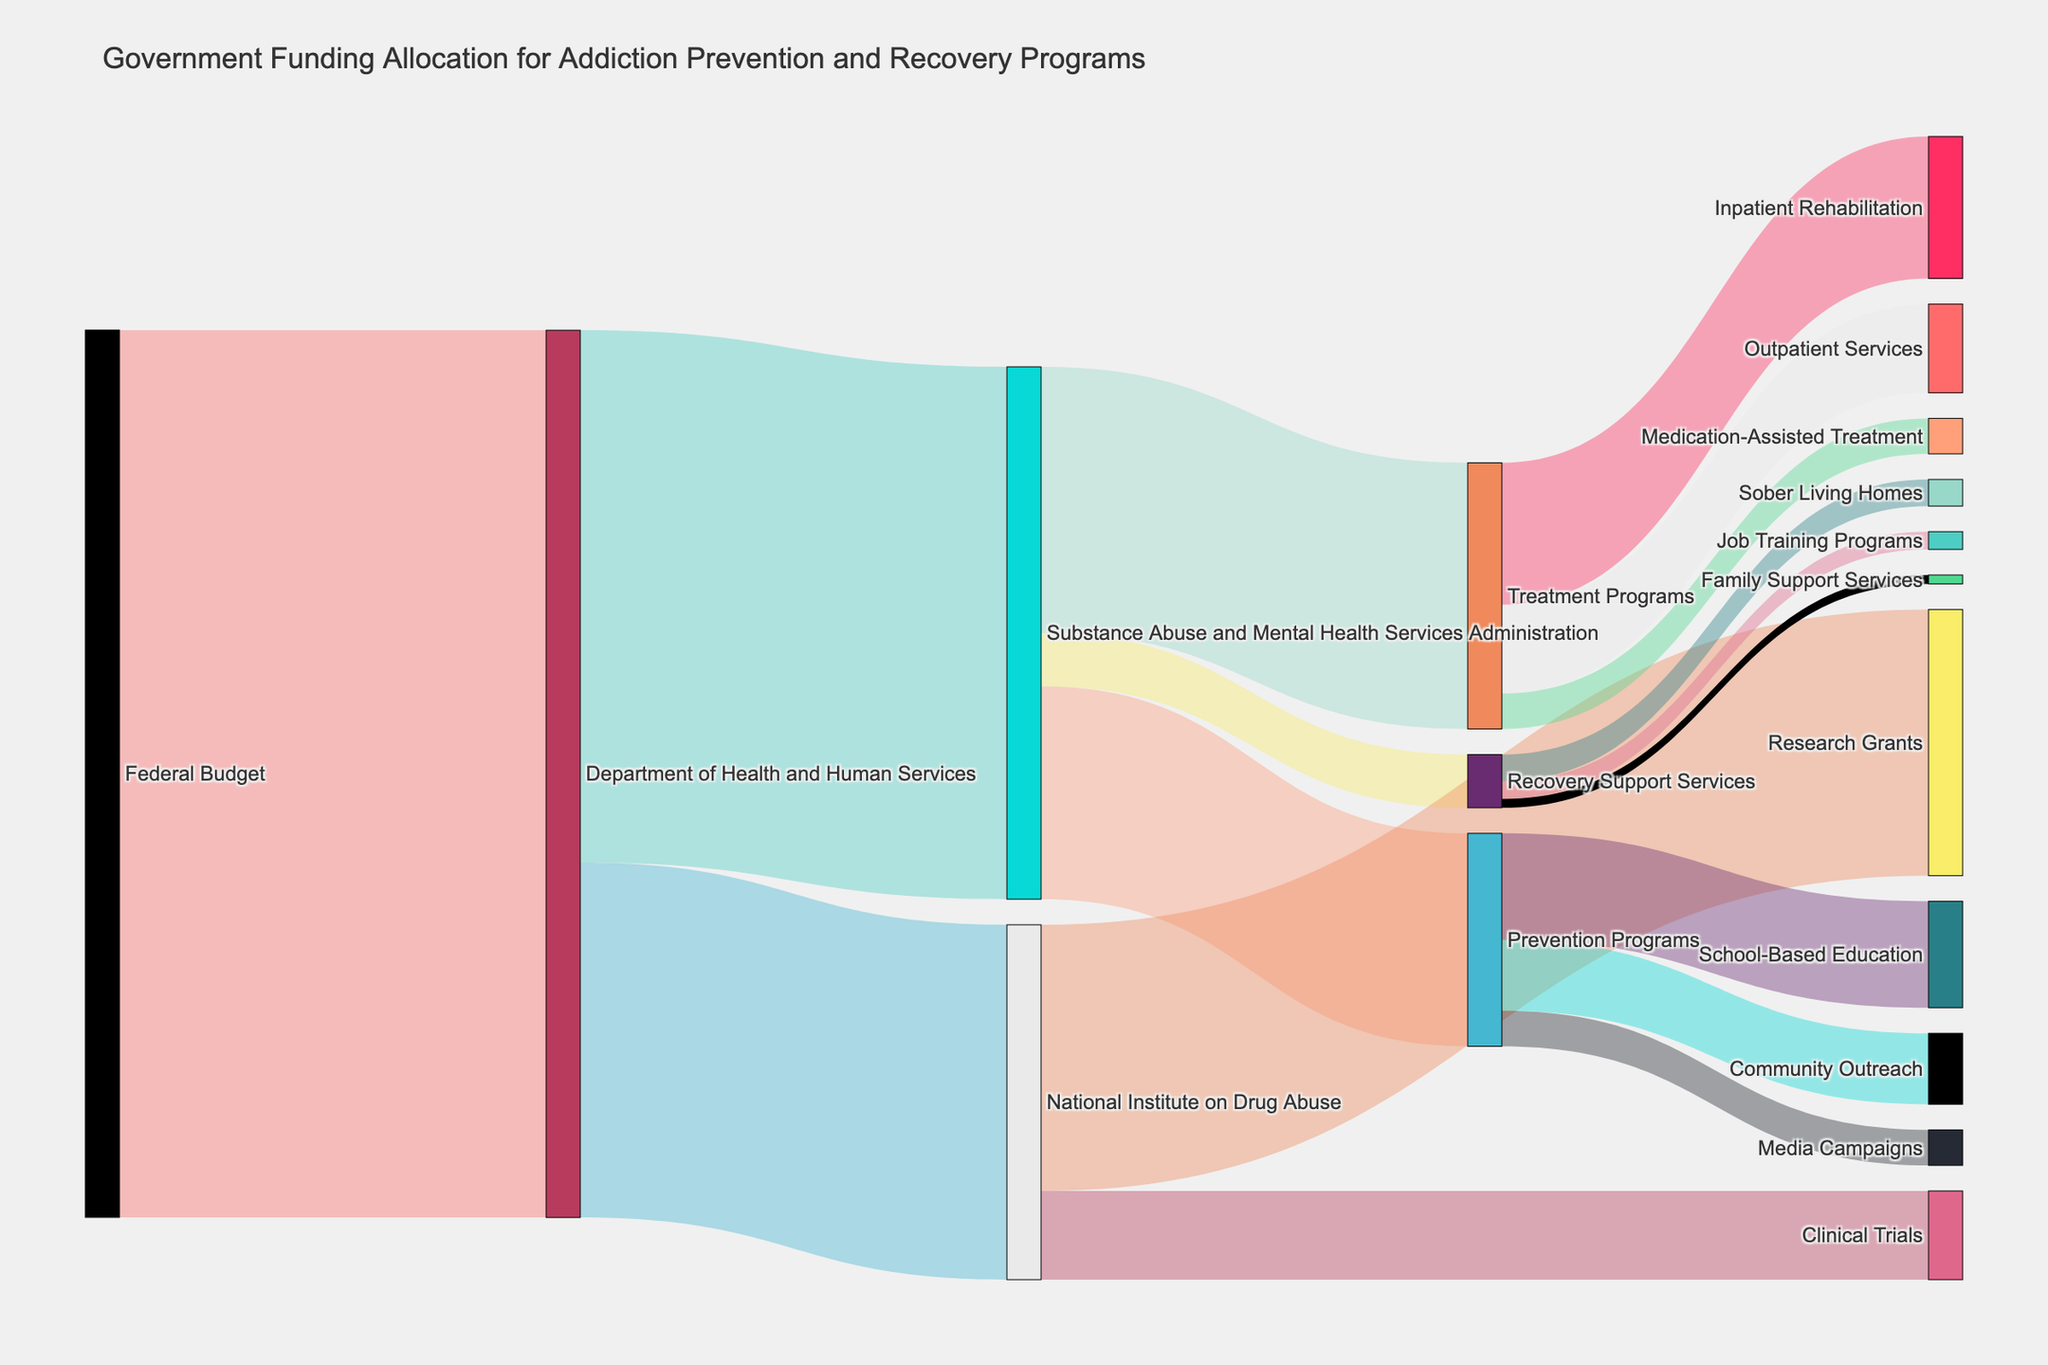What is the main source of funding that is depicted in the Sankey Diagram? The Sankey Diagram shows the flow of funds starting from one main source labeled "Federal Budget" and it progresses to various departments and programs.
Answer: Federal Budget How much total funding is allocated to the Department of Health and Human Services from the Federal Budget? The diagram illustrates that the "Federal Budget" allocates 5000 units to the "Department of Health and Human Services".
Answer: 5000 Of the funding allocated to the Department of Health and Human Services, how much goes to the Substance Abuse and Mental Health Services Administration? The diagram shows the amount flowing from the "Department of Health and Human Services" to the "Substance Abuse and Mental Health Services Administration", which is depicted as 3000 units.
Answer: 3000 What percentage of funding from the Substance Abuse and Mental Health Services Administration is allocated to Prevention Programs? The funding from the Substance Abuse and Mental Health Services Administration to Prevention Programs is 1200 units, while the total amount provided to this administration is 3000 units. Calculation: (1200/3000) * 100 = 40%
Answer: 40% Which program under the Substance Abuse and Mental Health Services Administration receives the least amount of funding? The diagram shows three programs under the Substance Abuse and Mental Health Services Administration: Prevention Programs (1200), Treatment Programs (1500), and Recovery Support Services (300). Recovery Support Services receives the least.
Answer: Recovery Support Services How much funding goes towards School-Based Education from Prevention Programs? The diagram indicates that Prevention Programs allocate 600 units to School-Based Education.
Answer: 600 Compare the funding amounts for Outpatient Services and Inpatient Rehabilitation under Treatment Programs. Treatment Programs allocate 800 units to Inpatient Rehabilitation and 500 units to Outpatient Services, making Inpatient Rehabilitation the higher funded program.
Answer: Inpatient Rehabilitation has more funding What is the total funding allocated to Treatment Programs, combining its subcategories? By summing the amounts given to Inpatient Rehabilitation (800), Outpatient Services (500), and Medication-Assisted Treatment (200), the total funding is 800 + 500 + 200 = 1500 units.
Answer: 1500 Which program under Recovery Support Services receives the most funding? Recovery Support Services include Sober Living Homes (150 units), Job Training Programs (100 units), and Family Support Services (50 units). Sober Living Homes receive the most funding.
Answer: Sober Living Homes How do the funds allocated to National Institute on Drug Abuse's Clinical Trials compare to those for Substance Abuse and Mental Health Services Administration's Recovery Support Services? The Clinical Trials under the National Institute on Drug Abuse receive 500 units, while Recovery Support Services under the Substance Abuse and Mental Health Services Administration receive 300 units. Clinical Trials receive more funding.
Answer: Clinical Trials receive more 